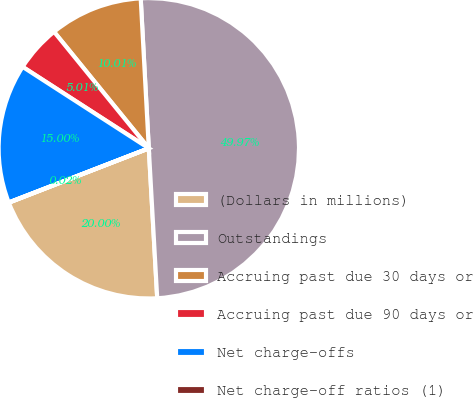<chart> <loc_0><loc_0><loc_500><loc_500><pie_chart><fcel>(Dollars in millions)<fcel>Outstandings<fcel>Accruing past due 30 days or<fcel>Accruing past due 90 days or<fcel>Net charge-offs<fcel>Net charge-off ratios (1)<nl><fcel>20.0%<fcel>49.97%<fcel>10.01%<fcel>5.01%<fcel>15.0%<fcel>0.02%<nl></chart> 